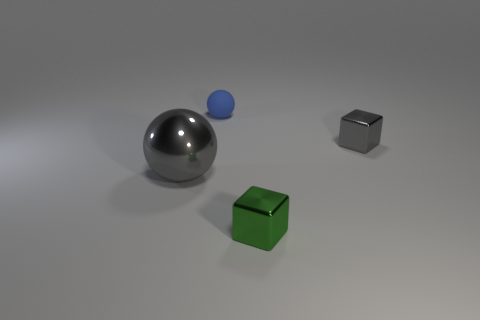Are there any other things that have the same size as the gray shiny sphere?
Ensure brevity in your answer.  No. How many cubes have the same size as the blue rubber sphere?
Make the answer very short. 2. The gray metal cube is what size?
Ensure brevity in your answer.  Small. There is a small ball; how many small gray shiny things are behind it?
Give a very brief answer. 0. What is the shape of the small gray object that is made of the same material as the small green block?
Offer a very short reply. Cube. Is the number of small gray blocks that are to the left of the small gray cube less than the number of shiny blocks in front of the metallic ball?
Your answer should be very brief. Yes. Is the number of large green blocks greater than the number of cubes?
Ensure brevity in your answer.  No. What is the material of the green cube?
Your response must be concise. Metal. There is a tiny metallic thing behind the tiny green block; what color is it?
Provide a succinct answer. Gray. Is the number of tiny spheres in front of the tiny blue matte ball greater than the number of large gray metallic objects right of the gray ball?
Provide a succinct answer. No. 